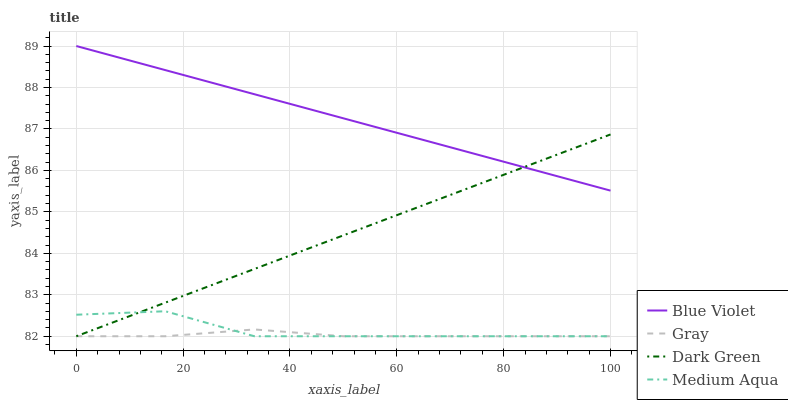Does Gray have the minimum area under the curve?
Answer yes or no. Yes. Does Blue Violet have the maximum area under the curve?
Answer yes or no. Yes. Does Medium Aqua have the minimum area under the curve?
Answer yes or no. No. Does Medium Aqua have the maximum area under the curve?
Answer yes or no. No. Is Blue Violet the smoothest?
Answer yes or no. Yes. Is Medium Aqua the roughest?
Answer yes or no. Yes. Is Medium Aqua the smoothest?
Answer yes or no. No. Is Blue Violet the roughest?
Answer yes or no. No. Does Gray have the lowest value?
Answer yes or no. Yes. Does Blue Violet have the lowest value?
Answer yes or no. No. Does Blue Violet have the highest value?
Answer yes or no. Yes. Does Medium Aqua have the highest value?
Answer yes or no. No. Is Gray less than Blue Violet?
Answer yes or no. Yes. Is Blue Violet greater than Gray?
Answer yes or no. Yes. Does Dark Green intersect Medium Aqua?
Answer yes or no. Yes. Is Dark Green less than Medium Aqua?
Answer yes or no. No. Is Dark Green greater than Medium Aqua?
Answer yes or no. No. Does Gray intersect Blue Violet?
Answer yes or no. No. 